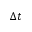<formula> <loc_0><loc_0><loc_500><loc_500>\Delta t</formula> 